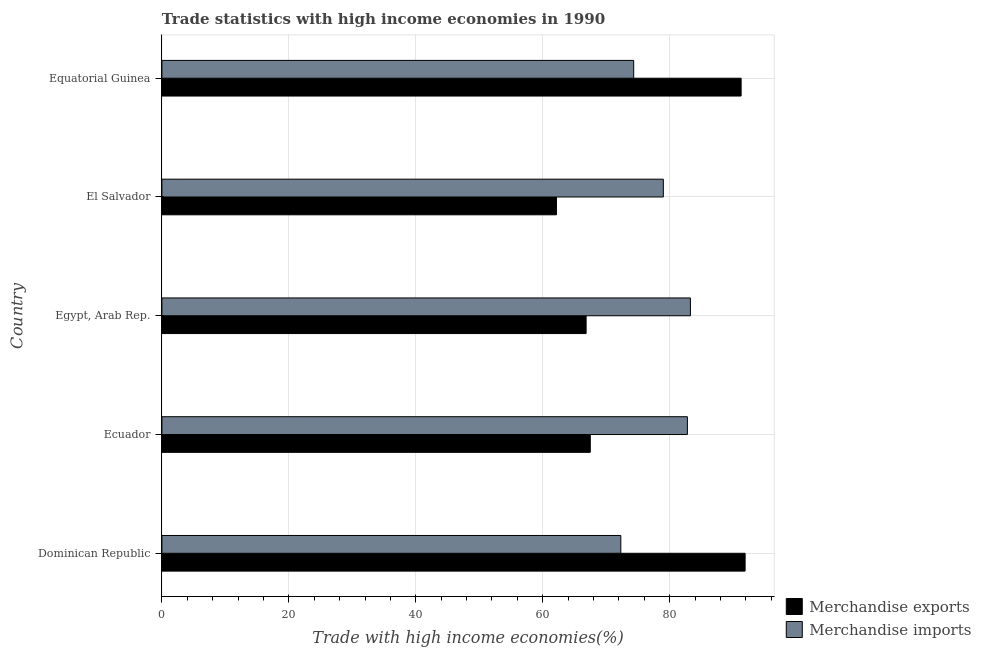How many different coloured bars are there?
Your answer should be compact. 2. How many groups of bars are there?
Make the answer very short. 5. Are the number of bars per tick equal to the number of legend labels?
Make the answer very short. Yes. How many bars are there on the 2nd tick from the top?
Offer a very short reply. 2. What is the label of the 2nd group of bars from the top?
Your response must be concise. El Salvador. In how many cases, is the number of bars for a given country not equal to the number of legend labels?
Give a very brief answer. 0. What is the merchandise exports in Dominican Republic?
Your answer should be very brief. 91.88. Across all countries, what is the maximum merchandise exports?
Give a very brief answer. 91.88. Across all countries, what is the minimum merchandise imports?
Your answer should be compact. 72.29. In which country was the merchandise exports maximum?
Your answer should be very brief. Dominican Republic. In which country was the merchandise imports minimum?
Provide a succinct answer. Dominican Republic. What is the total merchandise imports in the graph?
Your response must be concise. 391.65. What is the difference between the merchandise imports in Dominican Republic and that in El Salvador?
Provide a succinct answer. -6.7. What is the difference between the merchandise exports in Equatorial Guinea and the merchandise imports in El Salvador?
Keep it short and to the point. 12.26. What is the average merchandise imports per country?
Offer a very short reply. 78.33. What is the difference between the merchandise exports and merchandise imports in El Salvador?
Your answer should be very brief. -16.84. In how many countries, is the merchandise exports greater than 24 %?
Ensure brevity in your answer.  5. What is the ratio of the merchandise imports in Dominican Republic to that in El Salvador?
Offer a very short reply. 0.92. Is the merchandise imports in Dominican Republic less than that in Equatorial Guinea?
Offer a terse response. Yes. Is the difference between the merchandise imports in Dominican Republic and Equatorial Guinea greater than the difference between the merchandise exports in Dominican Republic and Equatorial Guinea?
Provide a succinct answer. No. What is the difference between the highest and the second highest merchandise exports?
Provide a succinct answer. 0.63. What is the difference between the highest and the lowest merchandise imports?
Provide a succinct answer. 10.96. Is the sum of the merchandise imports in Dominican Republic and Egypt, Arab Rep. greater than the maximum merchandise exports across all countries?
Give a very brief answer. Yes. What does the 2nd bar from the top in Equatorial Guinea represents?
Offer a terse response. Merchandise exports. How many bars are there?
Offer a very short reply. 10. What is the difference between two consecutive major ticks on the X-axis?
Ensure brevity in your answer.  20. Does the graph contain any zero values?
Provide a short and direct response. No. Where does the legend appear in the graph?
Your response must be concise. Bottom right. What is the title of the graph?
Your answer should be very brief. Trade statistics with high income economies in 1990. Does "Drinking water services" appear as one of the legend labels in the graph?
Your response must be concise. No. What is the label or title of the X-axis?
Provide a succinct answer. Trade with high income economies(%). What is the label or title of the Y-axis?
Your response must be concise. Country. What is the Trade with high income economies(%) of Merchandise exports in Dominican Republic?
Keep it short and to the point. 91.88. What is the Trade with high income economies(%) of Merchandise imports in Dominican Republic?
Your answer should be very brief. 72.29. What is the Trade with high income economies(%) of Merchandise exports in Ecuador?
Keep it short and to the point. 67.49. What is the Trade with high income economies(%) of Merchandise imports in Ecuador?
Provide a short and direct response. 82.78. What is the Trade with high income economies(%) in Merchandise exports in Egypt, Arab Rep.?
Your answer should be very brief. 66.83. What is the Trade with high income economies(%) of Merchandise imports in Egypt, Arab Rep.?
Your response must be concise. 83.26. What is the Trade with high income economies(%) in Merchandise exports in El Salvador?
Provide a short and direct response. 62.15. What is the Trade with high income economies(%) of Merchandise imports in El Salvador?
Provide a succinct answer. 78.99. What is the Trade with high income economies(%) of Merchandise exports in Equatorial Guinea?
Provide a short and direct response. 91.25. What is the Trade with high income economies(%) of Merchandise imports in Equatorial Guinea?
Offer a very short reply. 74.32. Across all countries, what is the maximum Trade with high income economies(%) of Merchandise exports?
Give a very brief answer. 91.88. Across all countries, what is the maximum Trade with high income economies(%) in Merchandise imports?
Make the answer very short. 83.26. Across all countries, what is the minimum Trade with high income economies(%) in Merchandise exports?
Offer a very short reply. 62.15. Across all countries, what is the minimum Trade with high income economies(%) of Merchandise imports?
Keep it short and to the point. 72.29. What is the total Trade with high income economies(%) in Merchandise exports in the graph?
Provide a short and direct response. 379.59. What is the total Trade with high income economies(%) in Merchandise imports in the graph?
Make the answer very short. 391.65. What is the difference between the Trade with high income economies(%) in Merchandise exports in Dominican Republic and that in Ecuador?
Your answer should be compact. 24.39. What is the difference between the Trade with high income economies(%) of Merchandise imports in Dominican Republic and that in Ecuador?
Your answer should be compact. -10.49. What is the difference between the Trade with high income economies(%) in Merchandise exports in Dominican Republic and that in Egypt, Arab Rep.?
Your answer should be compact. 25.05. What is the difference between the Trade with high income economies(%) of Merchandise imports in Dominican Republic and that in Egypt, Arab Rep.?
Ensure brevity in your answer.  -10.96. What is the difference between the Trade with high income economies(%) of Merchandise exports in Dominican Republic and that in El Salvador?
Offer a very short reply. 29.72. What is the difference between the Trade with high income economies(%) in Merchandise imports in Dominican Republic and that in El Salvador?
Provide a succinct answer. -6.7. What is the difference between the Trade with high income economies(%) of Merchandise exports in Dominican Republic and that in Equatorial Guinea?
Make the answer very short. 0.63. What is the difference between the Trade with high income economies(%) in Merchandise imports in Dominican Republic and that in Equatorial Guinea?
Keep it short and to the point. -2.03. What is the difference between the Trade with high income economies(%) of Merchandise exports in Ecuador and that in Egypt, Arab Rep.?
Provide a succinct answer. 0.66. What is the difference between the Trade with high income economies(%) of Merchandise imports in Ecuador and that in Egypt, Arab Rep.?
Your response must be concise. -0.47. What is the difference between the Trade with high income economies(%) of Merchandise exports in Ecuador and that in El Salvador?
Keep it short and to the point. 5.33. What is the difference between the Trade with high income economies(%) in Merchandise imports in Ecuador and that in El Salvador?
Give a very brief answer. 3.79. What is the difference between the Trade with high income economies(%) of Merchandise exports in Ecuador and that in Equatorial Guinea?
Offer a terse response. -23.76. What is the difference between the Trade with high income economies(%) of Merchandise imports in Ecuador and that in Equatorial Guinea?
Provide a short and direct response. 8.46. What is the difference between the Trade with high income economies(%) of Merchandise exports in Egypt, Arab Rep. and that in El Salvador?
Your answer should be compact. 4.68. What is the difference between the Trade with high income economies(%) in Merchandise imports in Egypt, Arab Rep. and that in El Salvador?
Make the answer very short. 4.27. What is the difference between the Trade with high income economies(%) in Merchandise exports in Egypt, Arab Rep. and that in Equatorial Guinea?
Your answer should be very brief. -24.42. What is the difference between the Trade with high income economies(%) of Merchandise imports in Egypt, Arab Rep. and that in Equatorial Guinea?
Offer a very short reply. 8.93. What is the difference between the Trade with high income economies(%) of Merchandise exports in El Salvador and that in Equatorial Guinea?
Offer a very short reply. -29.1. What is the difference between the Trade with high income economies(%) in Merchandise imports in El Salvador and that in Equatorial Guinea?
Give a very brief answer. 4.67. What is the difference between the Trade with high income economies(%) in Merchandise exports in Dominican Republic and the Trade with high income economies(%) in Merchandise imports in Ecuador?
Offer a very short reply. 9.09. What is the difference between the Trade with high income economies(%) of Merchandise exports in Dominican Republic and the Trade with high income economies(%) of Merchandise imports in Egypt, Arab Rep.?
Offer a very short reply. 8.62. What is the difference between the Trade with high income economies(%) of Merchandise exports in Dominican Republic and the Trade with high income economies(%) of Merchandise imports in El Salvador?
Provide a short and direct response. 12.88. What is the difference between the Trade with high income economies(%) of Merchandise exports in Dominican Republic and the Trade with high income economies(%) of Merchandise imports in Equatorial Guinea?
Your response must be concise. 17.55. What is the difference between the Trade with high income economies(%) of Merchandise exports in Ecuador and the Trade with high income economies(%) of Merchandise imports in Egypt, Arab Rep.?
Give a very brief answer. -15.77. What is the difference between the Trade with high income economies(%) of Merchandise exports in Ecuador and the Trade with high income economies(%) of Merchandise imports in El Salvador?
Offer a terse response. -11.51. What is the difference between the Trade with high income economies(%) in Merchandise exports in Ecuador and the Trade with high income economies(%) in Merchandise imports in Equatorial Guinea?
Your answer should be very brief. -6.84. What is the difference between the Trade with high income economies(%) in Merchandise exports in Egypt, Arab Rep. and the Trade with high income economies(%) in Merchandise imports in El Salvador?
Ensure brevity in your answer.  -12.16. What is the difference between the Trade with high income economies(%) of Merchandise exports in Egypt, Arab Rep. and the Trade with high income economies(%) of Merchandise imports in Equatorial Guinea?
Offer a very short reply. -7.49. What is the difference between the Trade with high income economies(%) in Merchandise exports in El Salvador and the Trade with high income economies(%) in Merchandise imports in Equatorial Guinea?
Offer a very short reply. -12.17. What is the average Trade with high income economies(%) of Merchandise exports per country?
Your response must be concise. 75.92. What is the average Trade with high income economies(%) in Merchandise imports per country?
Your answer should be very brief. 78.33. What is the difference between the Trade with high income economies(%) of Merchandise exports and Trade with high income economies(%) of Merchandise imports in Dominican Republic?
Provide a short and direct response. 19.58. What is the difference between the Trade with high income economies(%) of Merchandise exports and Trade with high income economies(%) of Merchandise imports in Ecuador?
Your answer should be compact. -15.3. What is the difference between the Trade with high income economies(%) in Merchandise exports and Trade with high income economies(%) in Merchandise imports in Egypt, Arab Rep.?
Your answer should be very brief. -16.43. What is the difference between the Trade with high income economies(%) in Merchandise exports and Trade with high income economies(%) in Merchandise imports in El Salvador?
Give a very brief answer. -16.84. What is the difference between the Trade with high income economies(%) in Merchandise exports and Trade with high income economies(%) in Merchandise imports in Equatorial Guinea?
Provide a short and direct response. 16.92. What is the ratio of the Trade with high income economies(%) in Merchandise exports in Dominican Republic to that in Ecuador?
Ensure brevity in your answer.  1.36. What is the ratio of the Trade with high income economies(%) of Merchandise imports in Dominican Republic to that in Ecuador?
Offer a very short reply. 0.87. What is the ratio of the Trade with high income economies(%) in Merchandise exports in Dominican Republic to that in Egypt, Arab Rep.?
Your answer should be compact. 1.37. What is the ratio of the Trade with high income economies(%) of Merchandise imports in Dominican Republic to that in Egypt, Arab Rep.?
Offer a terse response. 0.87. What is the ratio of the Trade with high income economies(%) of Merchandise exports in Dominican Republic to that in El Salvador?
Ensure brevity in your answer.  1.48. What is the ratio of the Trade with high income economies(%) of Merchandise imports in Dominican Republic to that in El Salvador?
Provide a short and direct response. 0.92. What is the ratio of the Trade with high income economies(%) in Merchandise exports in Dominican Republic to that in Equatorial Guinea?
Offer a very short reply. 1.01. What is the ratio of the Trade with high income economies(%) of Merchandise imports in Dominican Republic to that in Equatorial Guinea?
Give a very brief answer. 0.97. What is the ratio of the Trade with high income economies(%) of Merchandise exports in Ecuador to that in Egypt, Arab Rep.?
Offer a terse response. 1.01. What is the ratio of the Trade with high income economies(%) in Merchandise imports in Ecuador to that in Egypt, Arab Rep.?
Your response must be concise. 0.99. What is the ratio of the Trade with high income economies(%) of Merchandise exports in Ecuador to that in El Salvador?
Offer a very short reply. 1.09. What is the ratio of the Trade with high income economies(%) of Merchandise imports in Ecuador to that in El Salvador?
Keep it short and to the point. 1.05. What is the ratio of the Trade with high income economies(%) in Merchandise exports in Ecuador to that in Equatorial Guinea?
Provide a short and direct response. 0.74. What is the ratio of the Trade with high income economies(%) in Merchandise imports in Ecuador to that in Equatorial Guinea?
Give a very brief answer. 1.11. What is the ratio of the Trade with high income economies(%) in Merchandise exports in Egypt, Arab Rep. to that in El Salvador?
Make the answer very short. 1.08. What is the ratio of the Trade with high income economies(%) in Merchandise imports in Egypt, Arab Rep. to that in El Salvador?
Offer a very short reply. 1.05. What is the ratio of the Trade with high income economies(%) in Merchandise exports in Egypt, Arab Rep. to that in Equatorial Guinea?
Your answer should be compact. 0.73. What is the ratio of the Trade with high income economies(%) in Merchandise imports in Egypt, Arab Rep. to that in Equatorial Guinea?
Your answer should be compact. 1.12. What is the ratio of the Trade with high income economies(%) of Merchandise exports in El Salvador to that in Equatorial Guinea?
Ensure brevity in your answer.  0.68. What is the ratio of the Trade with high income economies(%) in Merchandise imports in El Salvador to that in Equatorial Guinea?
Make the answer very short. 1.06. What is the difference between the highest and the second highest Trade with high income economies(%) in Merchandise exports?
Offer a very short reply. 0.63. What is the difference between the highest and the second highest Trade with high income economies(%) of Merchandise imports?
Make the answer very short. 0.47. What is the difference between the highest and the lowest Trade with high income economies(%) of Merchandise exports?
Offer a terse response. 29.72. What is the difference between the highest and the lowest Trade with high income economies(%) in Merchandise imports?
Provide a succinct answer. 10.96. 